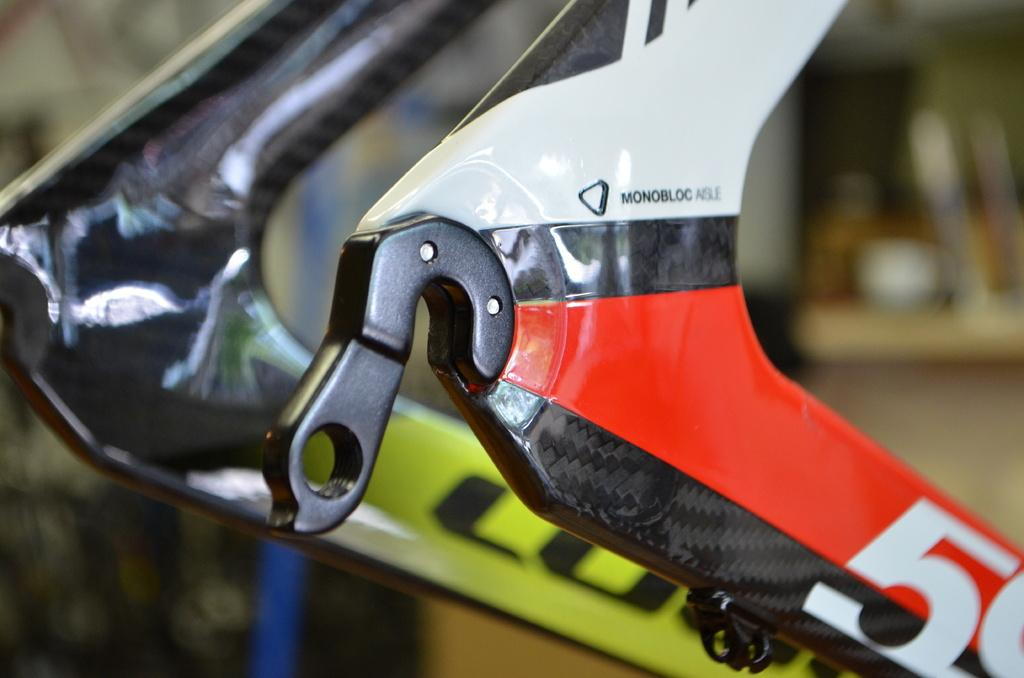What is the main subject in the center of the image? There is a metal object in the center of the image. Can you describe the background of the image? The background of the image is blurry. How does the chicken in the image express its feelings? There is no chicken present in the image, so it is not possible to answer that question. 